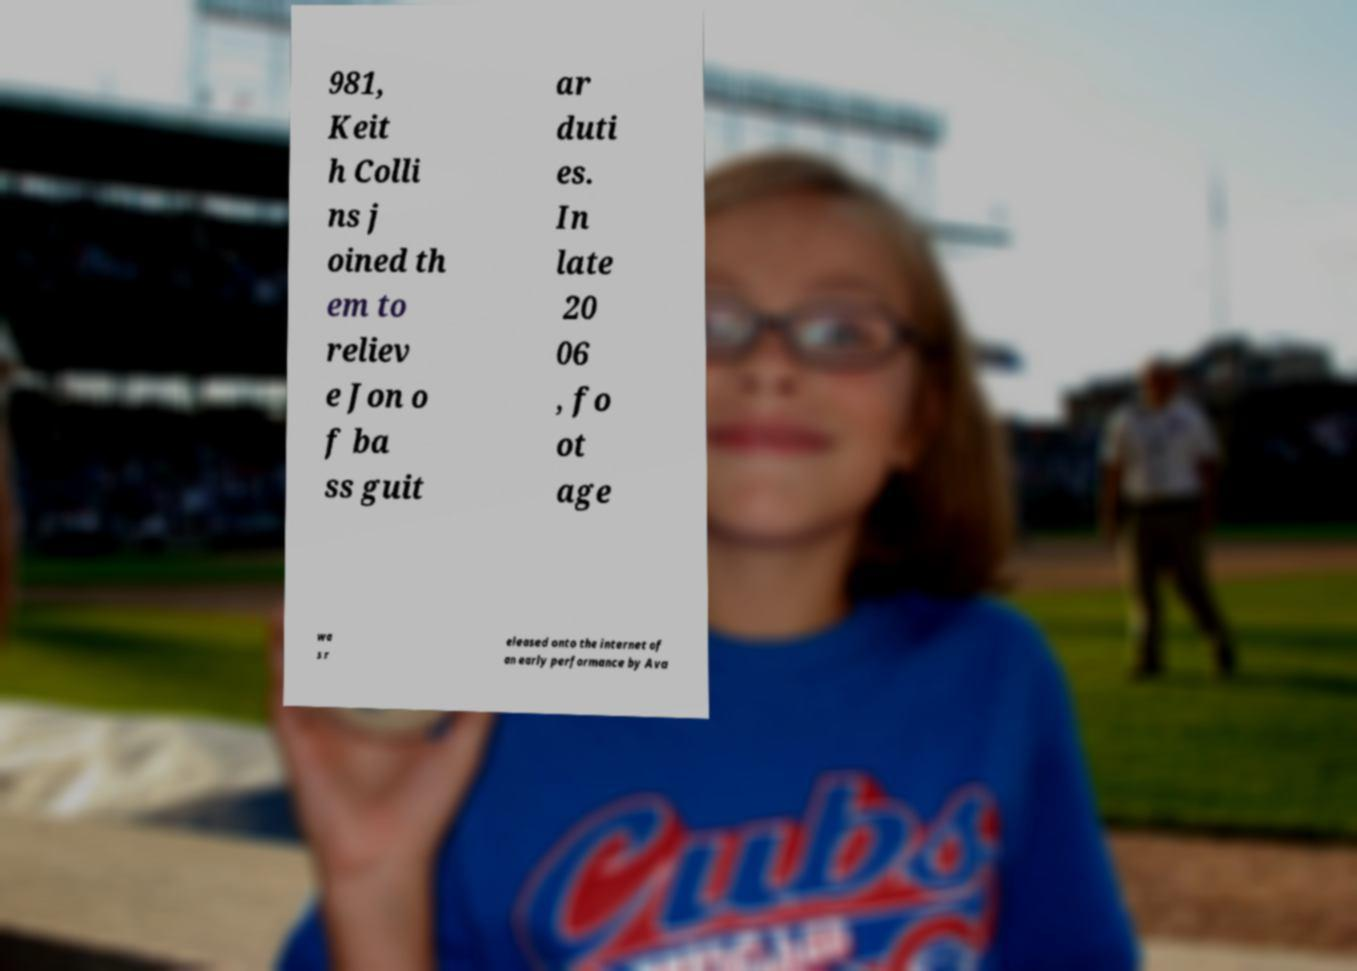Could you extract and type out the text from this image? 981, Keit h Colli ns j oined th em to reliev e Jon o f ba ss guit ar duti es. In late 20 06 , fo ot age wa s r eleased onto the internet of an early performance by Ava 